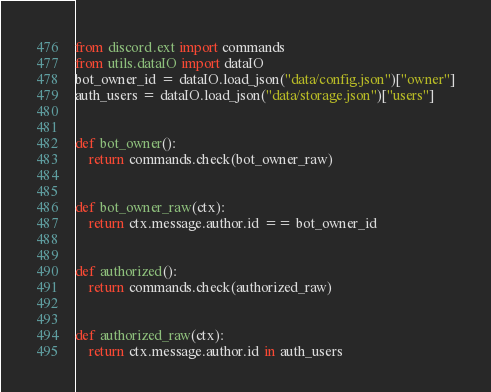<code> <loc_0><loc_0><loc_500><loc_500><_Python_>from discord.ext import commands
from utils.dataIO import dataIO
bot_owner_id = dataIO.load_json("data/config.json")["owner"]
auth_users = dataIO.load_json("data/storage.json")["users"]


def bot_owner():
    return commands.check(bot_owner_raw)


def bot_owner_raw(ctx):
    return ctx.message.author.id == bot_owner_id


def authorized():
    return commands.check(authorized_raw)


def authorized_raw(ctx):
    return ctx.message.author.id in auth_users
</code> 